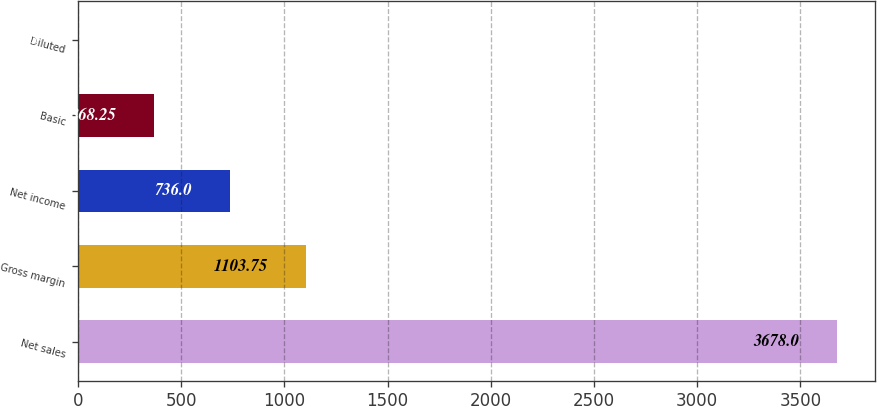Convert chart. <chart><loc_0><loc_0><loc_500><loc_500><bar_chart><fcel>Net sales<fcel>Gross margin<fcel>Net income<fcel>Basic<fcel>Diluted<nl><fcel>3678<fcel>1103.75<fcel>736<fcel>368.25<fcel>0.5<nl></chart> 